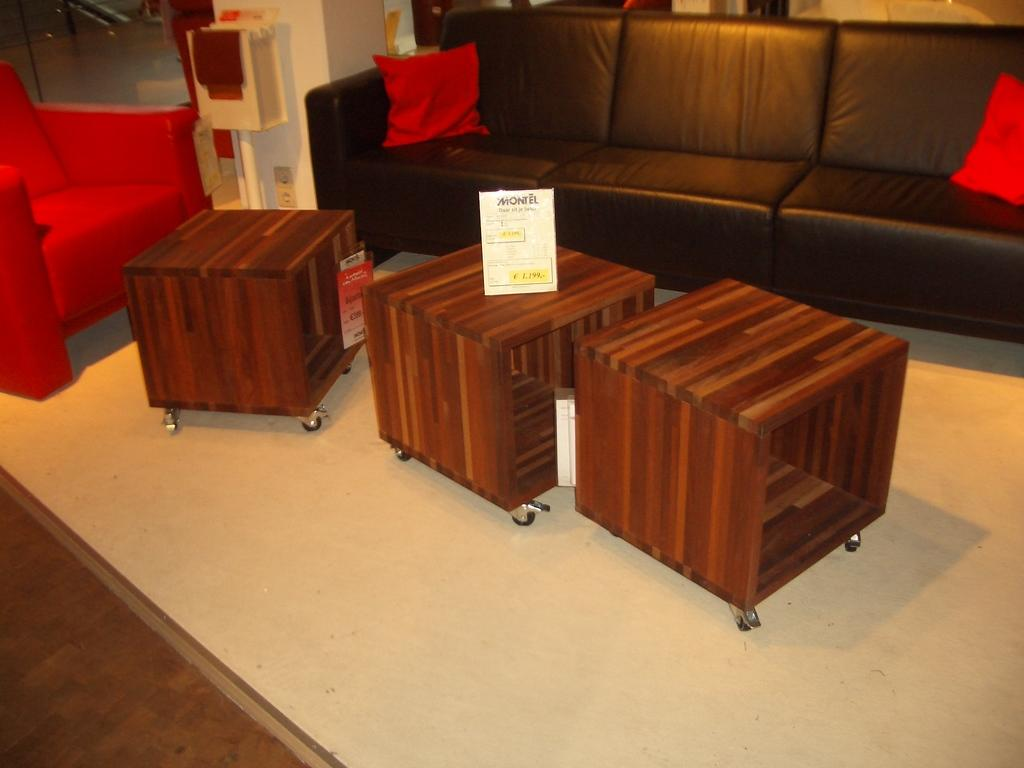What type of furniture is present in the image? There is a sofa bed, three tables, and a chair in the image. What type of yam is being used as a decorative item on the sofa bed? There is no yam present in the image; it features a sofa bed, tables, and a chair. Can you see a card being used as a coaster on one of the tables? There is no card present on any of the tables in the image. 